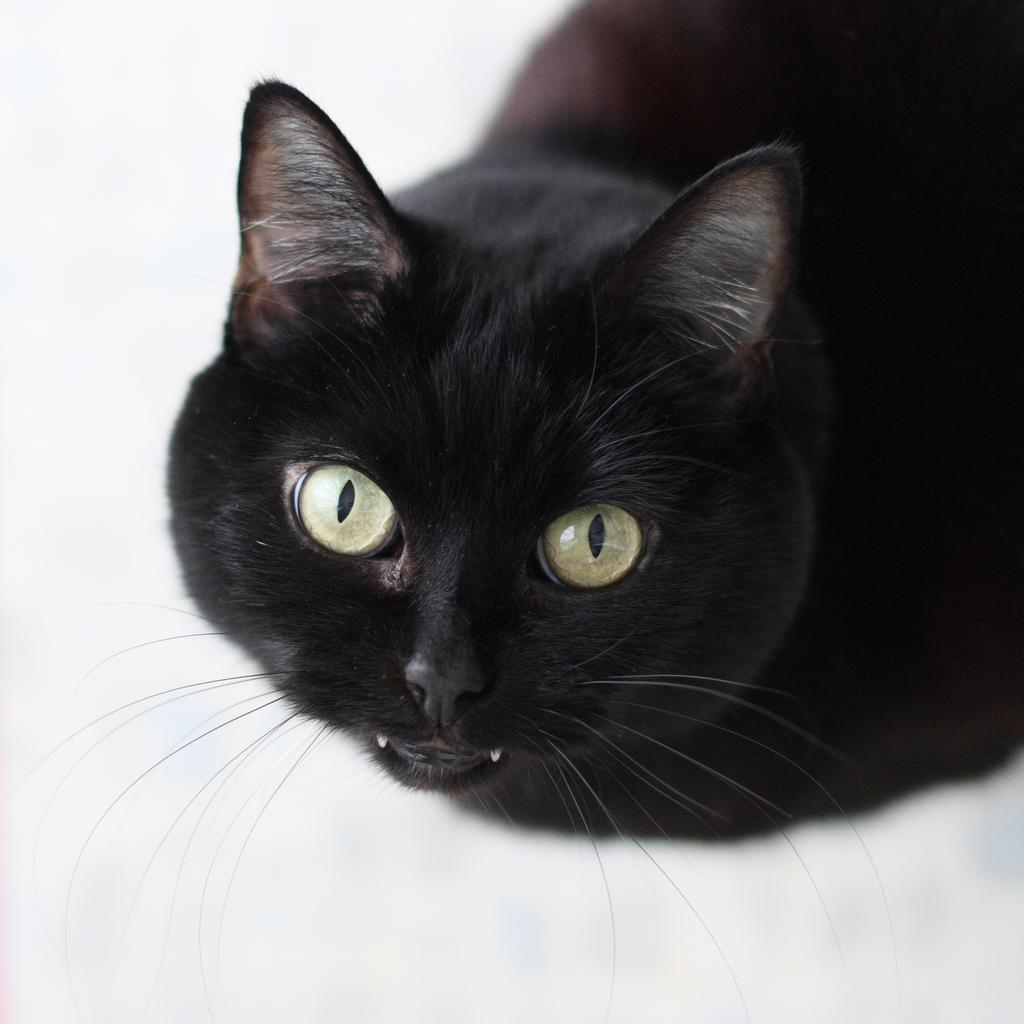What is the color of the surface in the image? The surface in the image is white. What type of animal can be seen on the white surface? There is a black cat on the white surface. What type of scissors can be seen on the black cat's nose in the image? There are no scissors or any other objects present on the black cat's nose in the image. 